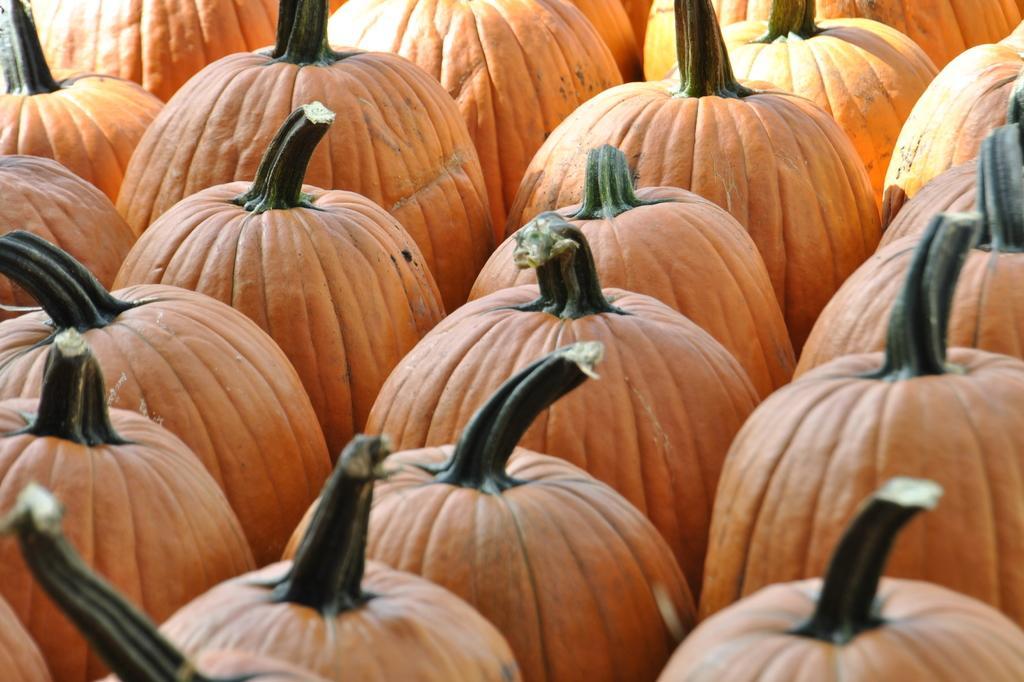In one or two sentences, can you explain what this image depicts? There are few Pumpkins which are in orange color. 